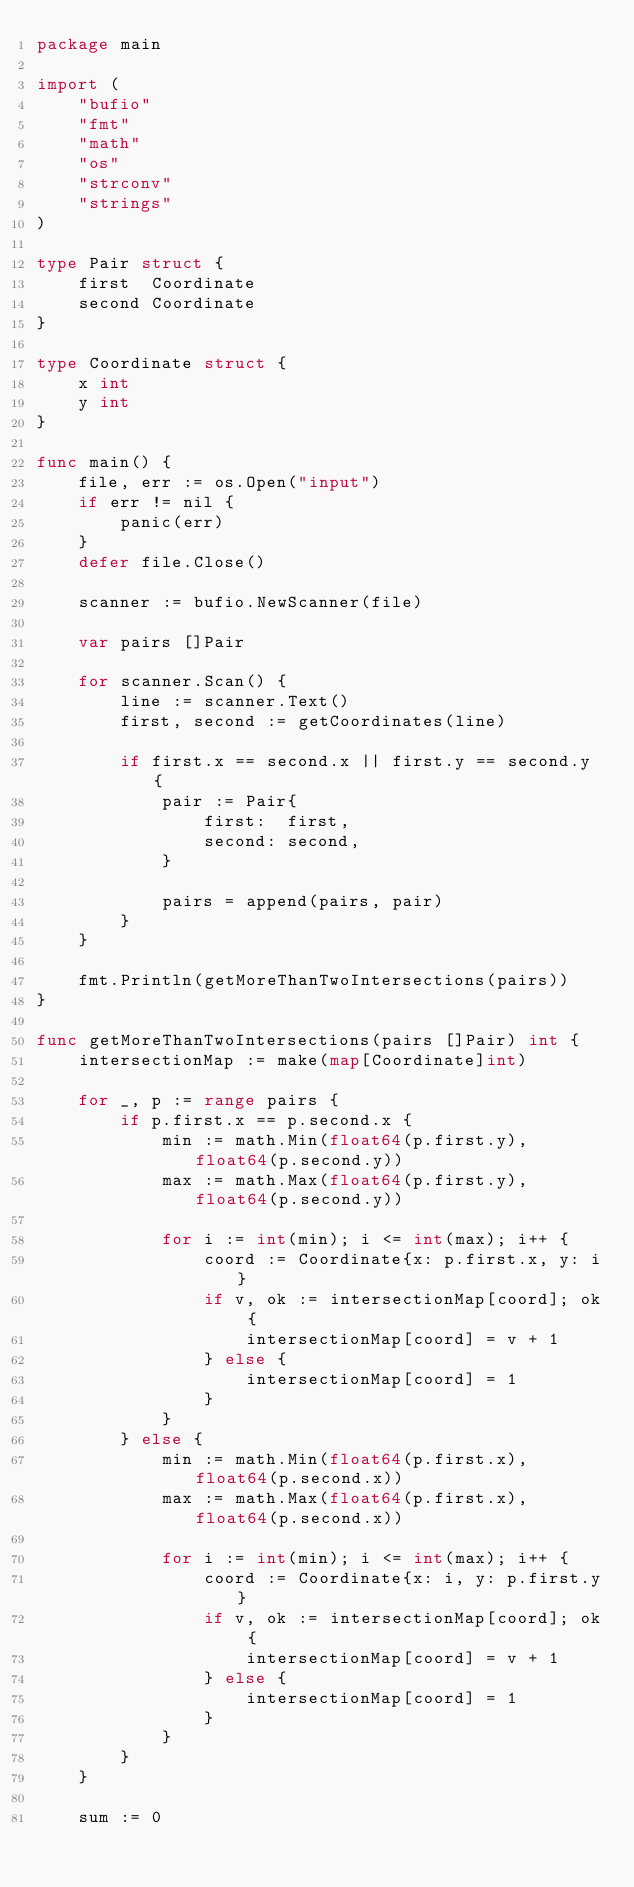<code> <loc_0><loc_0><loc_500><loc_500><_Go_>package main

import (
	"bufio"
	"fmt"
	"math"
	"os"
	"strconv"
	"strings"
)

type Pair struct {
	first  Coordinate
	second Coordinate
}

type Coordinate struct {
	x int
	y int
}

func main() {
	file, err := os.Open("input")
	if err != nil {
		panic(err)
	}
	defer file.Close()

	scanner := bufio.NewScanner(file)

	var pairs []Pair

	for scanner.Scan() {
		line := scanner.Text()
		first, second := getCoordinates(line)

		if first.x == second.x || first.y == second.y {
			pair := Pair{
				first:  first,
				second: second,
			}

			pairs = append(pairs, pair)
		}
	}

	fmt.Println(getMoreThanTwoIntersections(pairs))
}

func getMoreThanTwoIntersections(pairs []Pair) int {
	intersectionMap := make(map[Coordinate]int)

	for _, p := range pairs {
		if p.first.x == p.second.x {
			min := math.Min(float64(p.first.y), float64(p.second.y))
			max := math.Max(float64(p.first.y), float64(p.second.y))

			for i := int(min); i <= int(max); i++ {
				coord := Coordinate{x: p.first.x, y: i}
				if v, ok := intersectionMap[coord]; ok {
					intersectionMap[coord] = v + 1
				} else {
					intersectionMap[coord] = 1
				}
			}
		} else {
			min := math.Min(float64(p.first.x), float64(p.second.x))
			max := math.Max(float64(p.first.x), float64(p.second.x))

			for i := int(min); i <= int(max); i++ {
				coord := Coordinate{x: i, y: p.first.y}
				if v, ok := intersectionMap[coord]; ok {
					intersectionMap[coord] = v + 1
				} else {
					intersectionMap[coord] = 1
				}
			}
		}
	}

	sum := 0</code> 